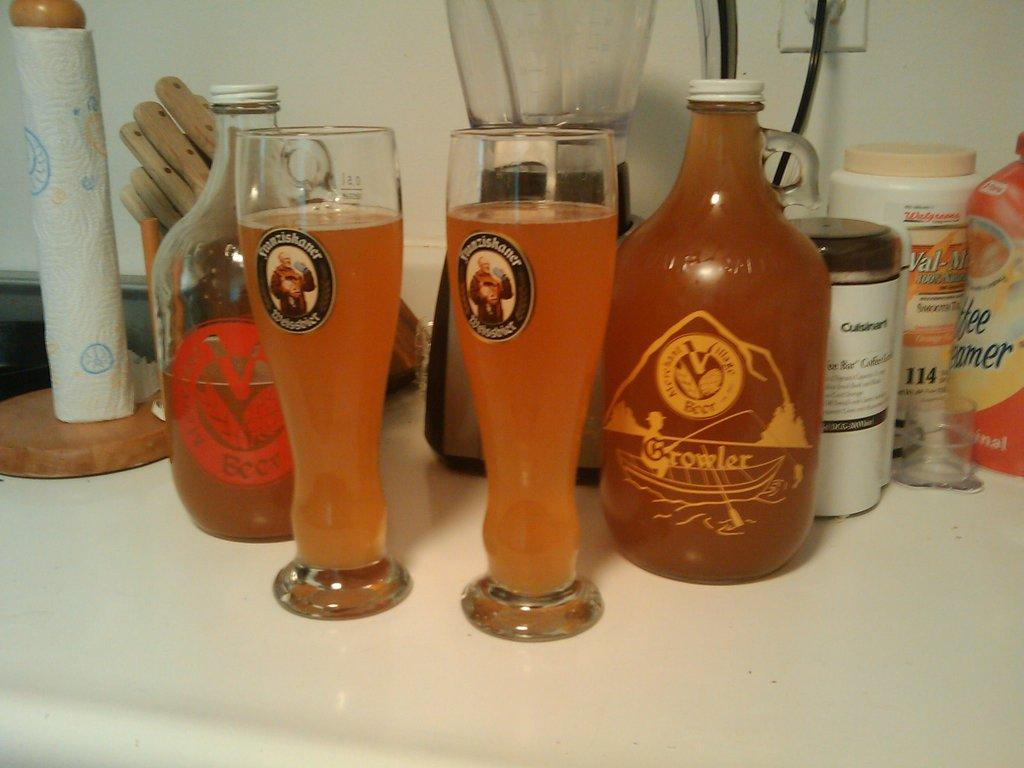<image>
Give a short and clear explanation of the subsequent image. Two glasses and two bottles of Growler sit upon a shelf. 